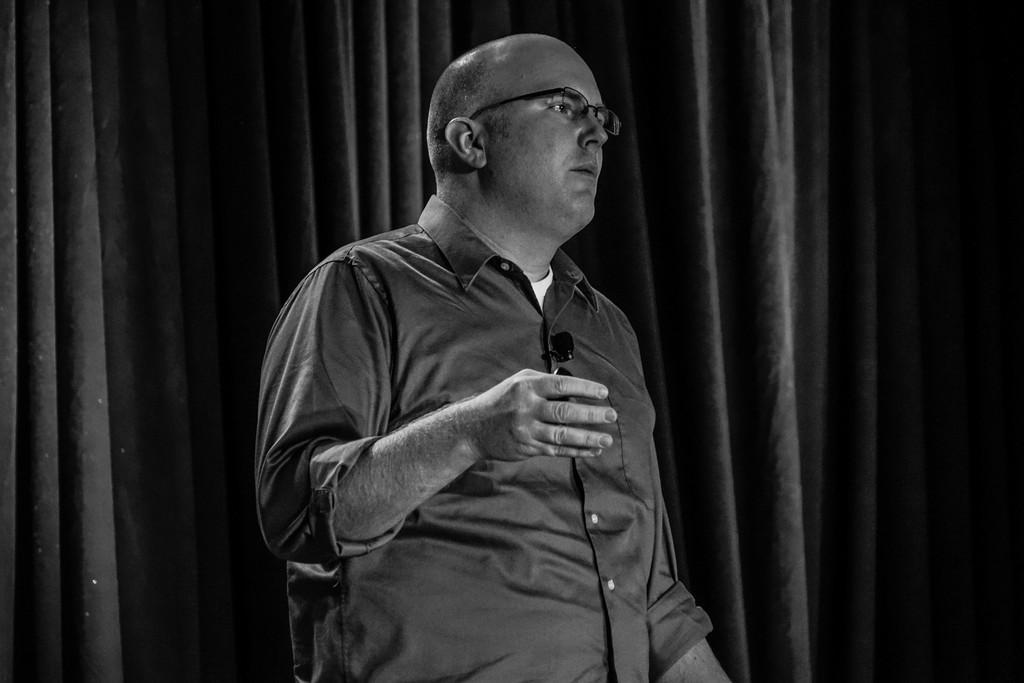Could you give a brief overview of what you see in this image? This image consists of a man wearing black shirt. And there is a mic on his shirt. In the background, there is a curtain black color. 